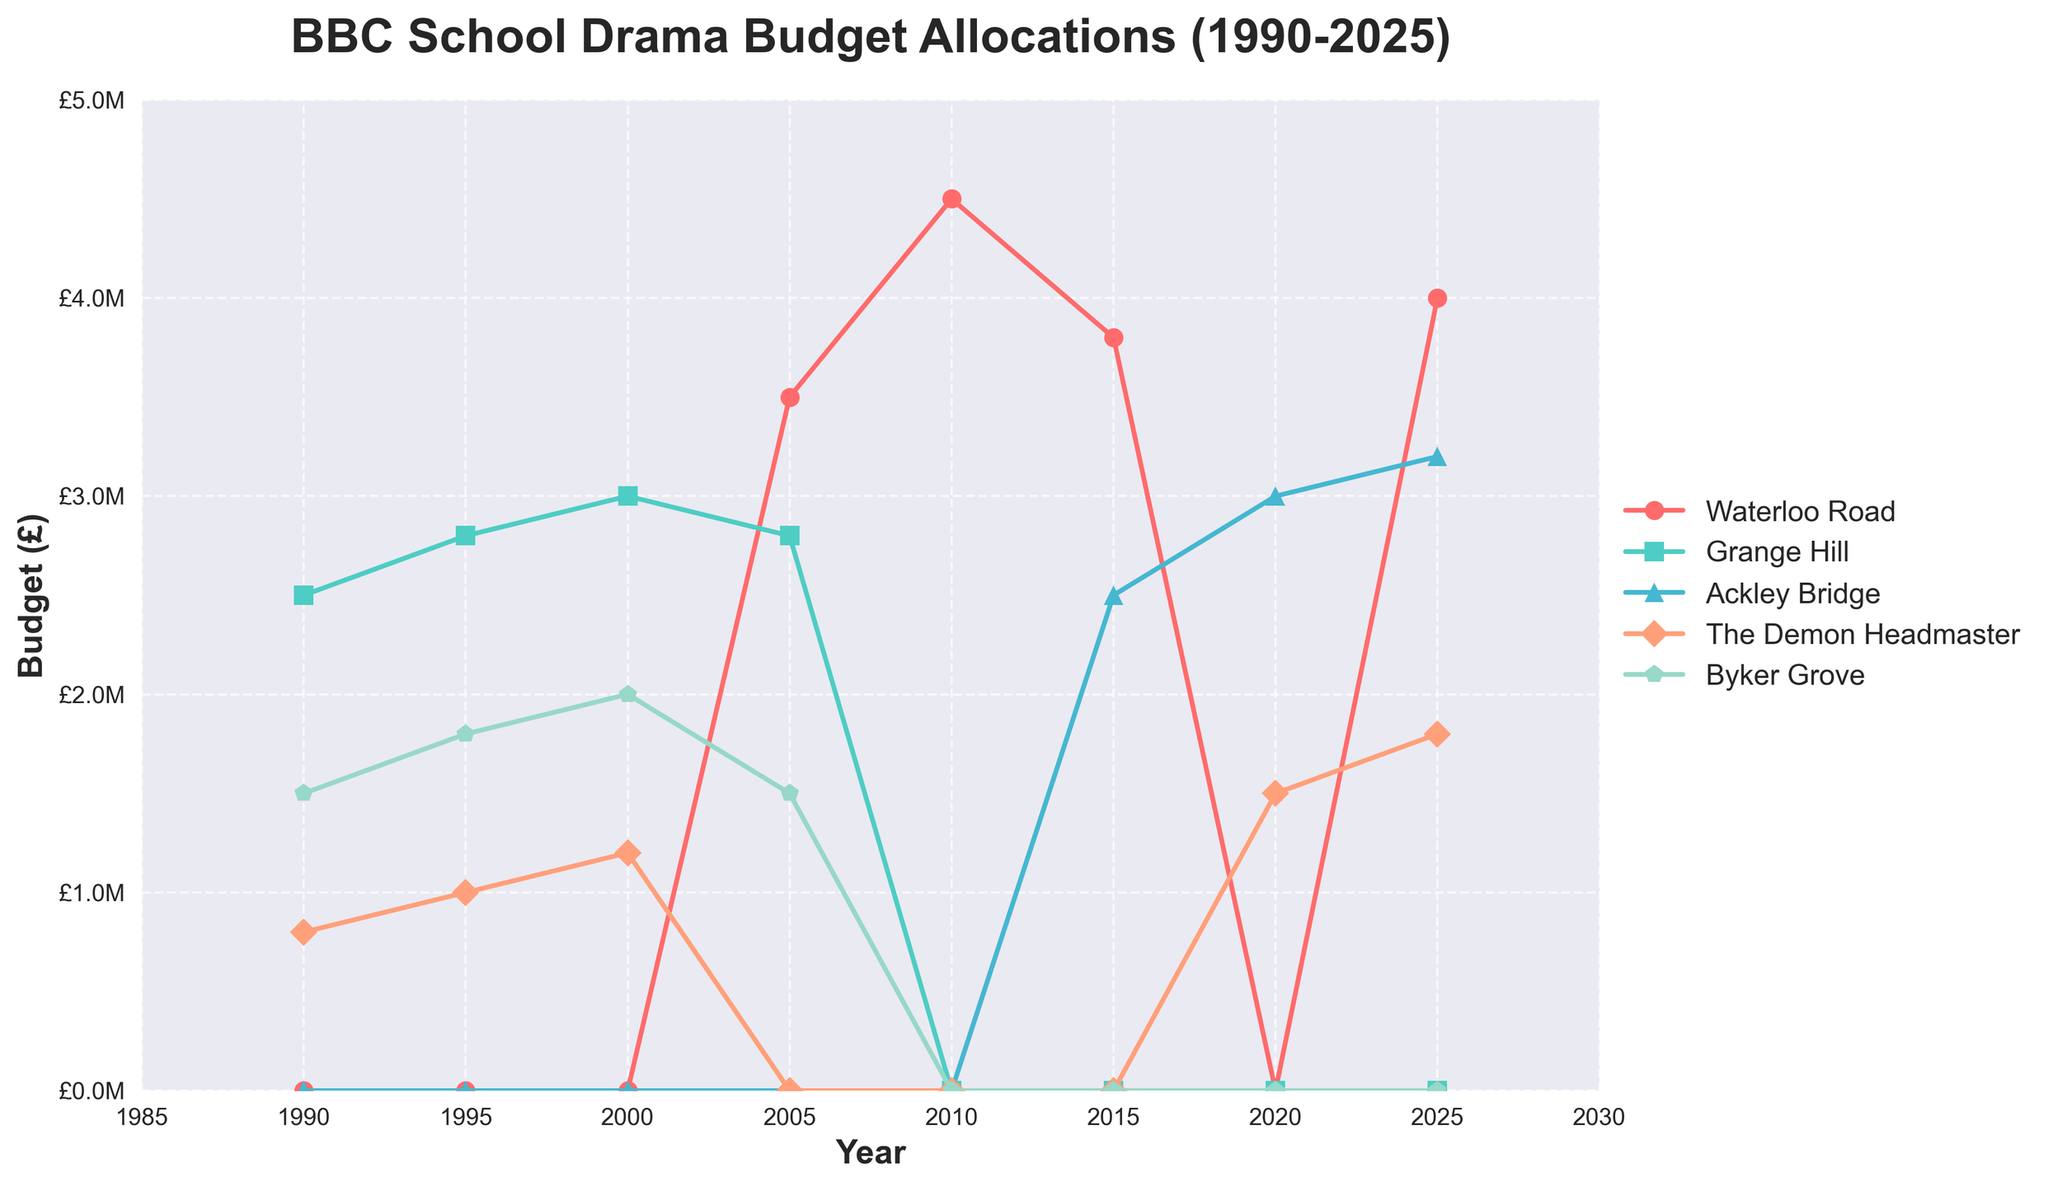What was the budget for Waterloo Road in 2010? Find the data point for Waterloo Road at the year 2010 on the curve corresponding to the color associated with Waterloo Road. The y-value of the point is £4,500,000.
Answer: £4,500,000 Which show had the highest budget allocation in 2025? Compare the y-values of the data points for different shows at the year 2025. Waterloo Road has the highest y-value at £4,000,000.
Answer: Waterloo Road How did the budget for Grange Hill change from 1990 to 2000? Find the y-values for Grange Hill at 1990 and 2000, then compute the difference: £3,000,000 - £2,500,000 = £500,000 increase.
Answer: Increased by £500,000 Which year did Byker Grove last receive a budget allocation according to the chart? Observe the last year on the x-axis where the Byker Grove curve exists; it is the year 2005.
Answer: 2005 Among the years 1990, 1995, and 2000, which year had the lowest budget allocation for The Demon Headmaster? Compare y-values for The Demon Headmaster at each of these years: £800,000 (1990), £1,000,000 (1995), £1,200,000 (2000). The lowest is £800,000 in 1990.
Answer: 1990 What is the sum of budgets for Ackley Bridge from 2015 to 2025? Add the y-values for Ackley Bridge for the years 2015, 2020, and 2025: £2,500,000 + £3,000,000 + £3,200,000 = £8,700,000.
Answer: £8,700,000 Which show had zero budget allocation for the longest period? Identify the show whose curve is flat at zero for the longest stretch of time. Grange Hill from 2010 to 2025 (15 years) has the longest period.
Answer: Grange Hill In which year did Waterloo Road first receive a budget allocation? Locate the first year on the x-axis where the y-value for the Waterloo Road curve is non-zero. It is the year 2005.
Answer: 2005 What is the average budget allocation for Byker Grove from 1990 to 2005? Calculate the average of y-values for Byker Grove over these years: (£1,500,000 + £1,800,000 + £2,000,000 + £1,500,000)/4. Sum is £6,800,000. Average = £6,800,000 / 4 = £1,700,000.
Answer: £1,700,000 